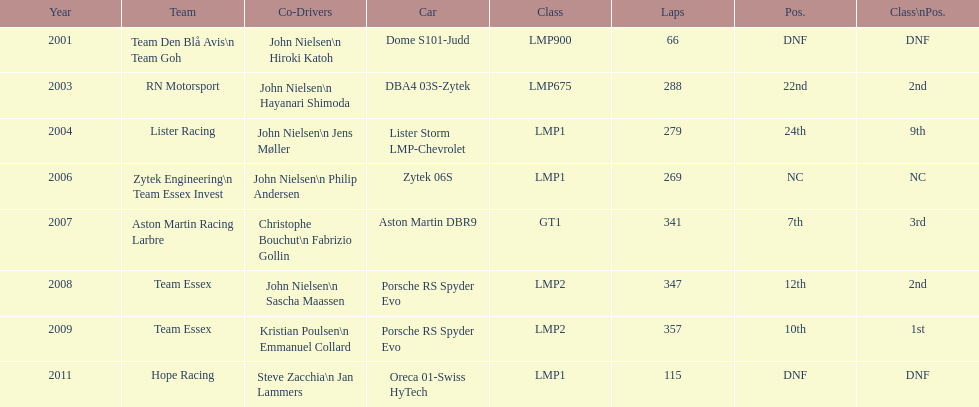On how many occasions was the final position over 20? 2. 